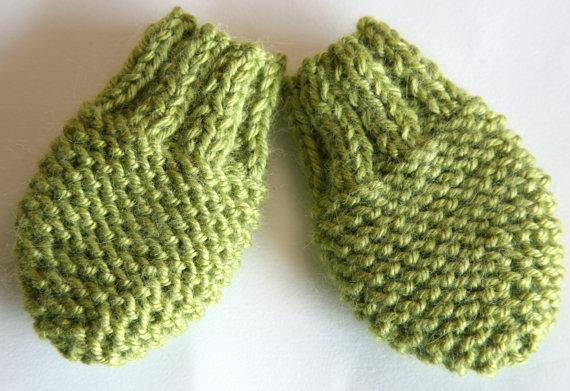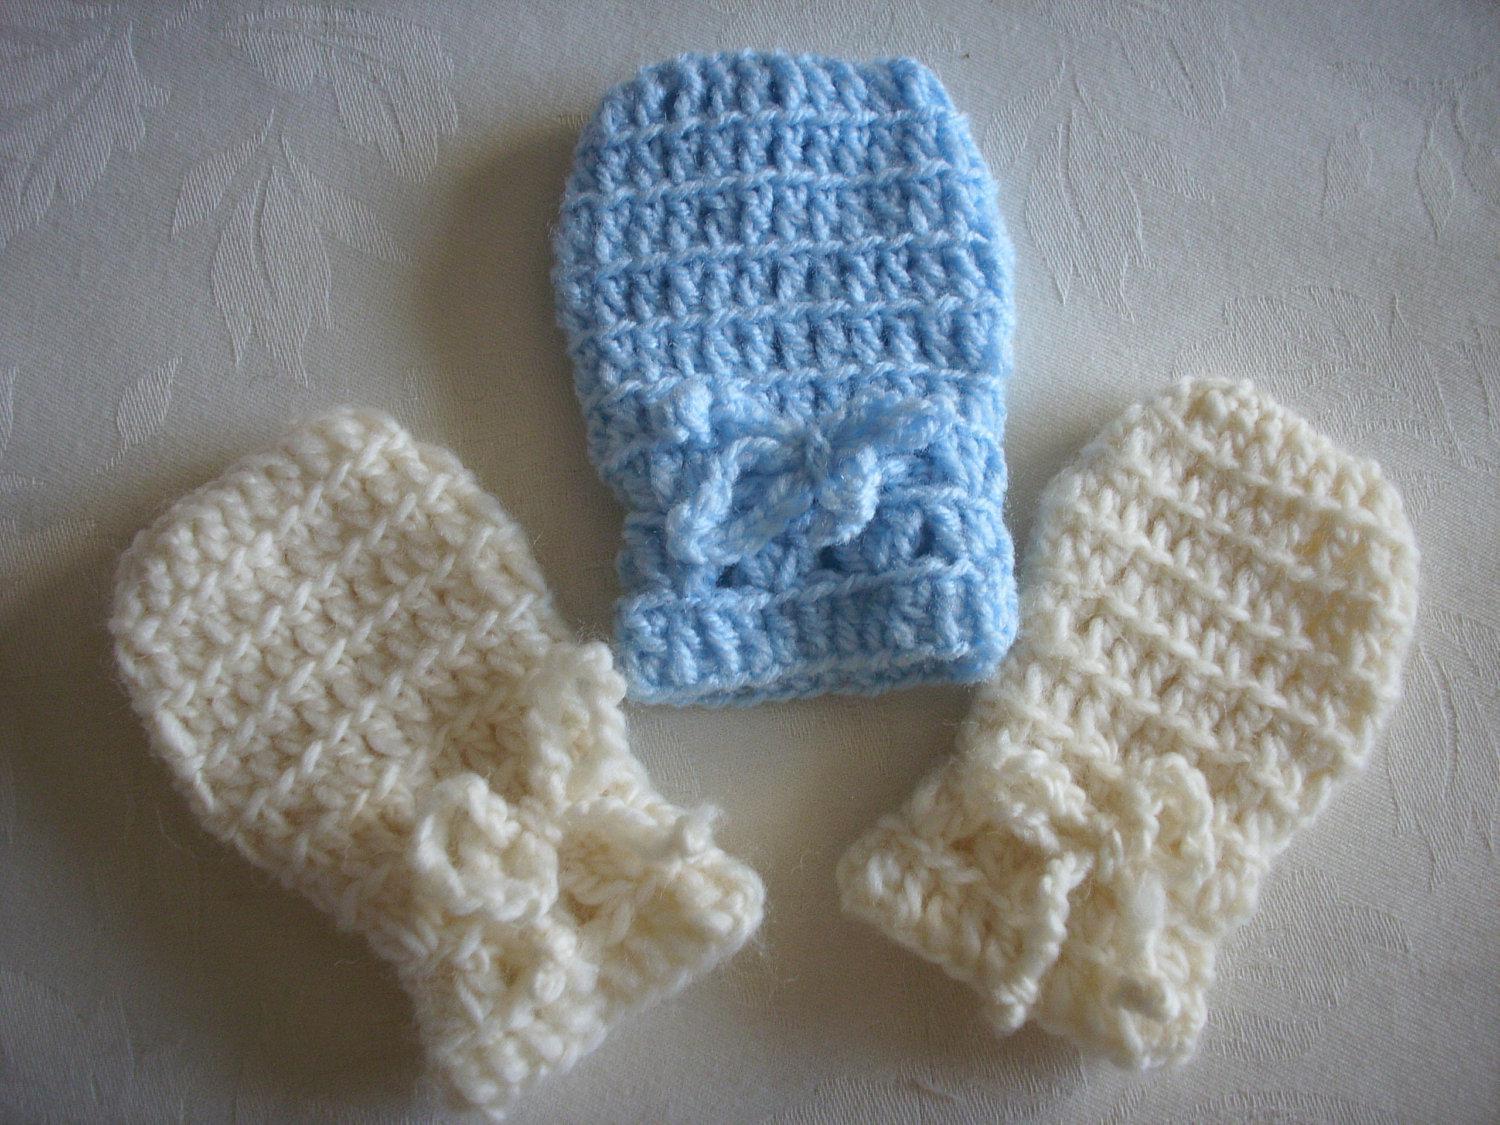The first image is the image on the left, the second image is the image on the right. Analyze the images presented: Is the assertion "One image shows at least one knitted mitten modelled on a human hand." valid? Answer yes or no. No. The first image is the image on the left, the second image is the image on the right. Assess this claim about the two images: "The right image contains at least two mittens.". Correct or not? Answer yes or no. Yes. 